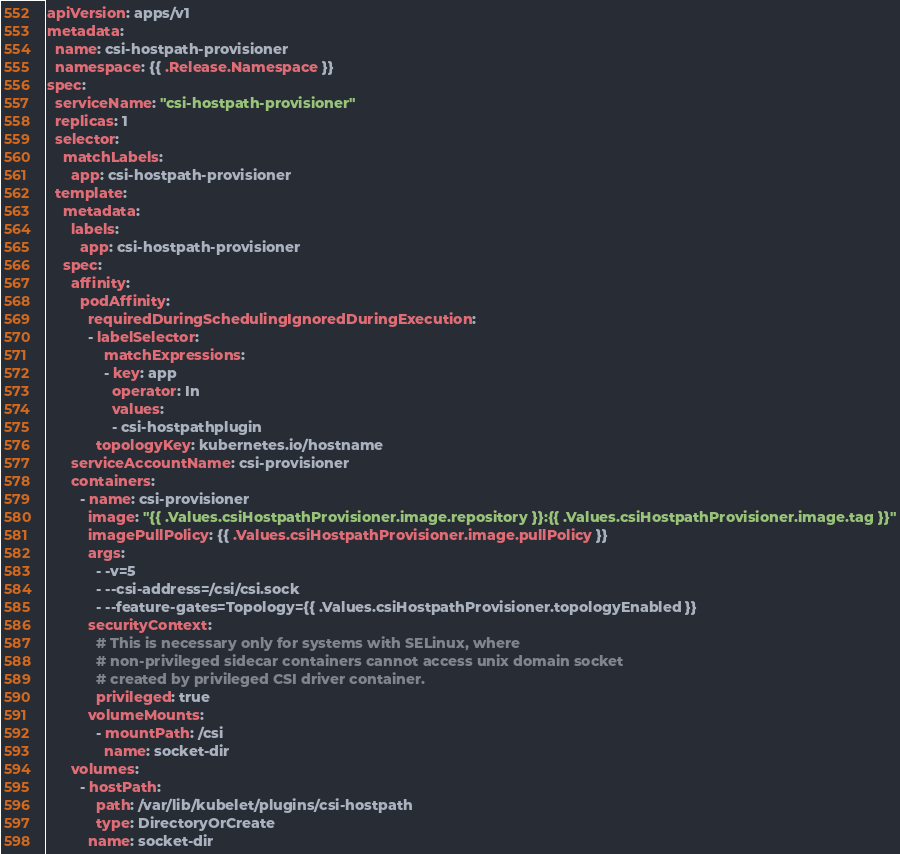Convert code to text. <code><loc_0><loc_0><loc_500><loc_500><_YAML_>apiVersion: apps/v1
metadata:
  name: csi-hostpath-provisioner
  namespace: {{ .Release.Namespace }}
spec:
  serviceName: "csi-hostpath-provisioner"
  replicas: 1
  selector:
    matchLabels:
      app: csi-hostpath-provisioner
  template:
    metadata:
      labels:
        app: csi-hostpath-provisioner
    spec:
      affinity:
        podAffinity:
          requiredDuringSchedulingIgnoredDuringExecution:
          - labelSelector:
              matchExpressions:
              - key: app
                operator: In
                values:
                - csi-hostpathplugin
            topologyKey: kubernetes.io/hostname
      serviceAccountName: csi-provisioner
      containers:
        - name: csi-provisioner
          image: "{{ .Values.csiHostpathProvisioner.image.repository }}:{{ .Values.csiHostpathProvisioner.image.tag }}"
          imagePullPolicy: {{ .Values.csiHostpathProvisioner.image.pullPolicy }}
          args:
            - -v=5
            - --csi-address=/csi/csi.sock
            - --feature-gates=Topology={{ .Values.csiHostpathProvisioner.topologyEnabled }}
          securityContext:
            # This is necessary only for systems with SELinux, where
            # non-privileged sidecar containers cannot access unix domain socket
            # created by privileged CSI driver container.
            privileged: true
          volumeMounts:
            - mountPath: /csi
              name: socket-dir
      volumes:
        - hostPath:
            path: /var/lib/kubelet/plugins/csi-hostpath
            type: DirectoryOrCreate
          name: socket-dir
</code> 